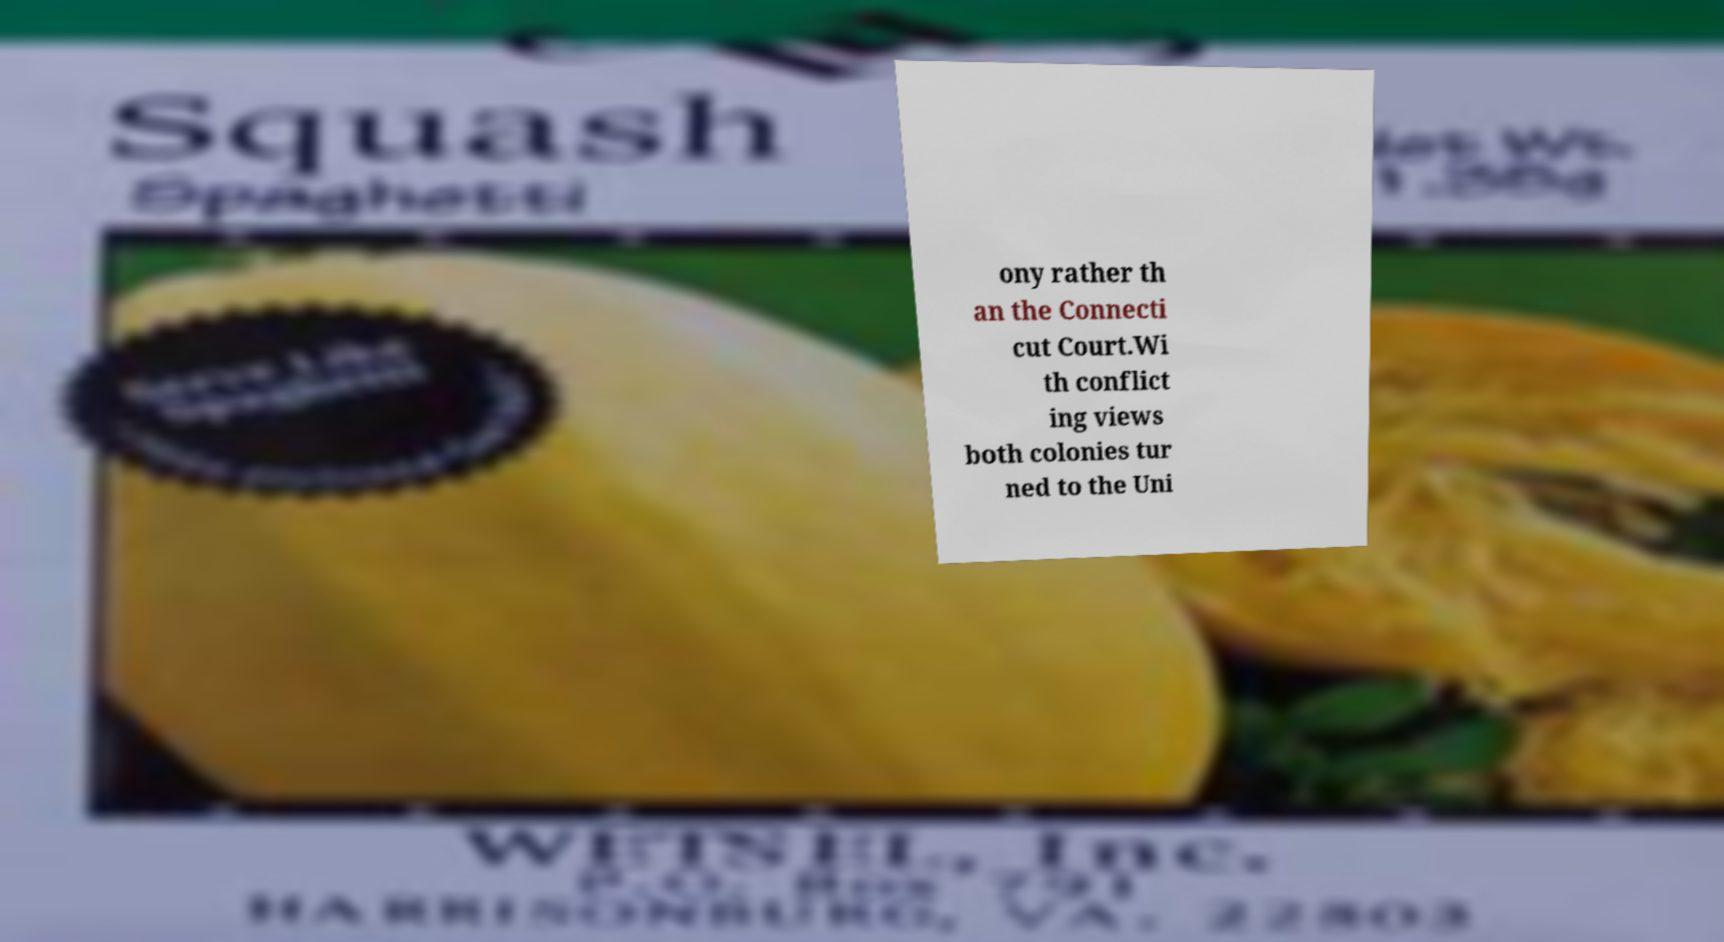Please identify and transcribe the text found in this image. ony rather th an the Connecti cut Court.Wi th conflict ing views both colonies tur ned to the Uni 